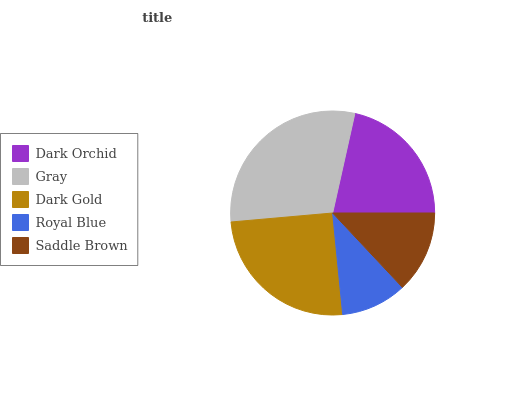Is Royal Blue the minimum?
Answer yes or no. Yes. Is Gray the maximum?
Answer yes or no. Yes. Is Dark Gold the minimum?
Answer yes or no. No. Is Dark Gold the maximum?
Answer yes or no. No. Is Gray greater than Dark Gold?
Answer yes or no. Yes. Is Dark Gold less than Gray?
Answer yes or no. Yes. Is Dark Gold greater than Gray?
Answer yes or no. No. Is Gray less than Dark Gold?
Answer yes or no. No. Is Dark Orchid the high median?
Answer yes or no. Yes. Is Dark Orchid the low median?
Answer yes or no. Yes. Is Royal Blue the high median?
Answer yes or no. No. Is Gray the low median?
Answer yes or no. No. 